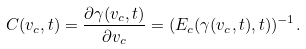<formula> <loc_0><loc_0><loc_500><loc_500>C ( v _ { c } , t ) = \frac { \partial \gamma ( v _ { c } , t ) } { \partial v _ { c } } = ( E _ { c } ( \gamma ( v _ { c } , t ) , t ) ) ^ { - 1 } .</formula> 